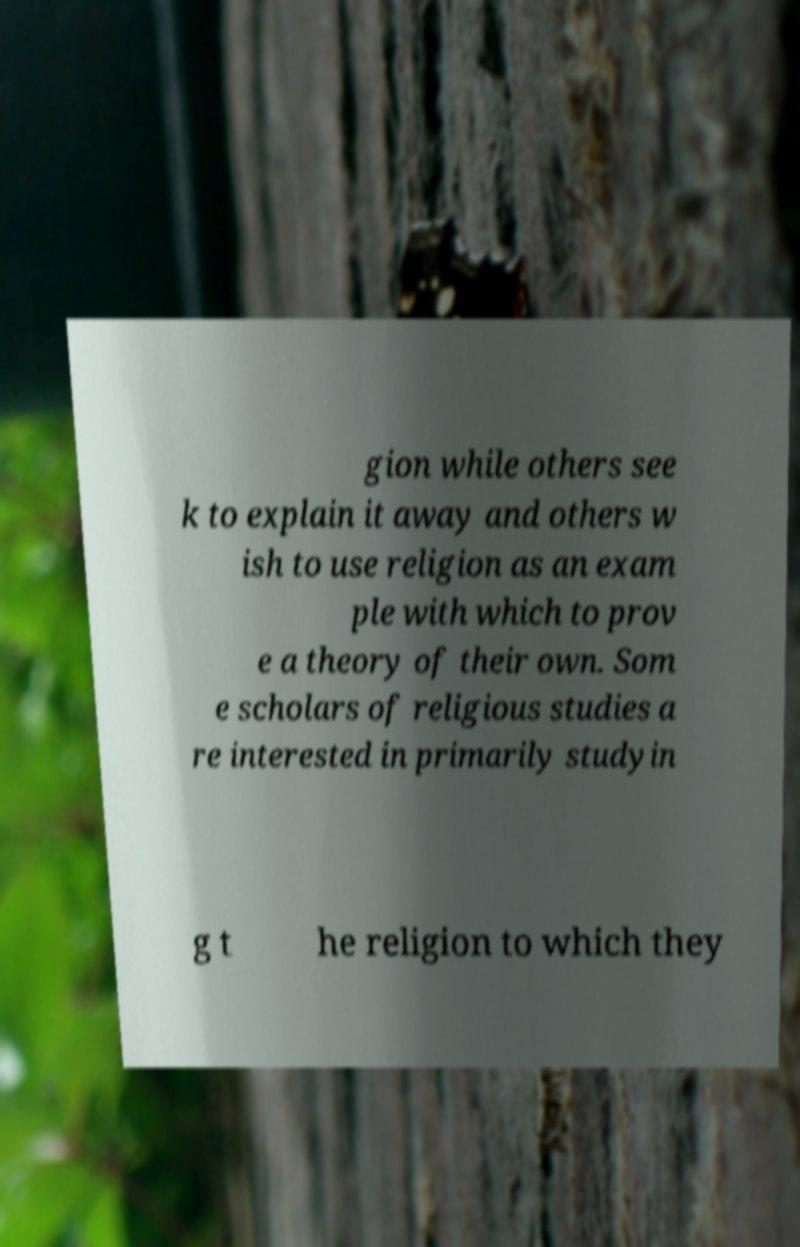There's text embedded in this image that I need extracted. Can you transcribe it verbatim? gion while others see k to explain it away and others w ish to use religion as an exam ple with which to prov e a theory of their own. Som e scholars of religious studies a re interested in primarily studyin g t he religion to which they 